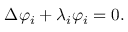Convert formula to latex. <formula><loc_0><loc_0><loc_500><loc_500>\Delta \varphi _ { i } + \lambda _ { i } \varphi _ { i } = 0 .</formula> 